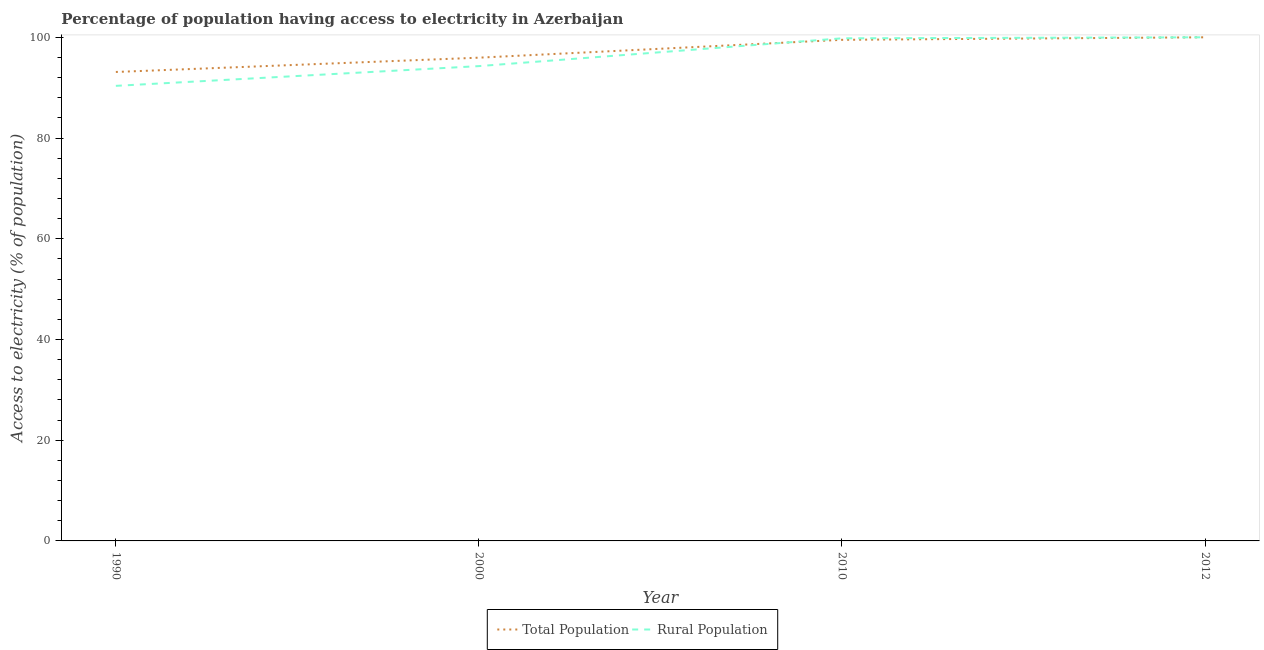How many different coloured lines are there?
Your answer should be compact. 2. What is the percentage of population having access to electricity in 2000?
Offer a terse response. 95.96. Across all years, what is the minimum percentage of population having access to electricity?
Your answer should be compact. 93.12. What is the total percentage of population having access to electricity in the graph?
Keep it short and to the point. 388.57. What is the difference between the percentage of population having access to electricity in 1990 and that in 2010?
Give a very brief answer. -6.38. What is the difference between the percentage of population having access to electricity in 1990 and the percentage of rural population having access to electricity in 2012?
Provide a succinct answer. -6.88. What is the average percentage of rural population having access to electricity per year?
Offer a very short reply. 96.11. What is the ratio of the percentage of population having access to electricity in 2000 to that in 2010?
Provide a succinct answer. 0.96. Is the percentage of population having access to electricity in 1990 less than that in 2000?
Your answer should be compact. Yes. What is the difference between the highest and the second highest percentage of rural population having access to electricity?
Offer a very short reply. 0.2. What is the difference between the highest and the lowest percentage of rural population having access to electricity?
Your answer should be compact. 9.64. In how many years, is the percentage of rural population having access to electricity greater than the average percentage of rural population having access to electricity taken over all years?
Keep it short and to the point. 2. Does the percentage of population having access to electricity monotonically increase over the years?
Provide a succinct answer. Yes. Is the percentage of rural population having access to electricity strictly less than the percentage of population having access to electricity over the years?
Your response must be concise. No. How many years are there in the graph?
Your response must be concise. 4. Are the values on the major ticks of Y-axis written in scientific E-notation?
Your response must be concise. No. Does the graph contain any zero values?
Your answer should be compact. No. How are the legend labels stacked?
Give a very brief answer. Horizontal. What is the title of the graph?
Give a very brief answer. Percentage of population having access to electricity in Azerbaijan. Does "Investments" appear as one of the legend labels in the graph?
Give a very brief answer. No. What is the label or title of the Y-axis?
Your answer should be very brief. Access to electricity (% of population). What is the Access to electricity (% of population) in Total Population in 1990?
Keep it short and to the point. 93.12. What is the Access to electricity (% of population) in Rural Population in 1990?
Provide a short and direct response. 90.36. What is the Access to electricity (% of population) in Total Population in 2000?
Ensure brevity in your answer.  95.96. What is the Access to electricity (% of population) in Rural Population in 2000?
Provide a short and direct response. 94.28. What is the Access to electricity (% of population) of Total Population in 2010?
Your response must be concise. 99.5. What is the Access to electricity (% of population) in Rural Population in 2010?
Your answer should be compact. 99.8. What is the Access to electricity (% of population) of Rural Population in 2012?
Offer a very short reply. 100. Across all years, what is the minimum Access to electricity (% of population) of Total Population?
Your answer should be very brief. 93.12. Across all years, what is the minimum Access to electricity (% of population) in Rural Population?
Make the answer very short. 90.36. What is the total Access to electricity (% of population) of Total Population in the graph?
Provide a succinct answer. 388.57. What is the total Access to electricity (% of population) of Rural Population in the graph?
Offer a terse response. 384.44. What is the difference between the Access to electricity (% of population) of Total Population in 1990 and that in 2000?
Keep it short and to the point. -2.84. What is the difference between the Access to electricity (% of population) in Rural Population in 1990 and that in 2000?
Provide a succinct answer. -3.92. What is the difference between the Access to electricity (% of population) in Total Population in 1990 and that in 2010?
Give a very brief answer. -6.38. What is the difference between the Access to electricity (% of population) in Rural Population in 1990 and that in 2010?
Keep it short and to the point. -9.44. What is the difference between the Access to electricity (% of population) of Total Population in 1990 and that in 2012?
Offer a terse response. -6.88. What is the difference between the Access to electricity (% of population) of Rural Population in 1990 and that in 2012?
Make the answer very short. -9.64. What is the difference between the Access to electricity (% of population) in Total Population in 2000 and that in 2010?
Provide a short and direct response. -3.54. What is the difference between the Access to electricity (% of population) of Rural Population in 2000 and that in 2010?
Give a very brief answer. -5.52. What is the difference between the Access to electricity (% of population) of Total Population in 2000 and that in 2012?
Your answer should be compact. -4.04. What is the difference between the Access to electricity (% of population) in Rural Population in 2000 and that in 2012?
Your answer should be very brief. -5.72. What is the difference between the Access to electricity (% of population) of Total Population in 1990 and the Access to electricity (% of population) of Rural Population in 2000?
Your response must be concise. -1.17. What is the difference between the Access to electricity (% of population) of Total Population in 1990 and the Access to electricity (% of population) of Rural Population in 2010?
Provide a short and direct response. -6.68. What is the difference between the Access to electricity (% of population) of Total Population in 1990 and the Access to electricity (% of population) of Rural Population in 2012?
Your response must be concise. -6.88. What is the difference between the Access to electricity (% of population) of Total Population in 2000 and the Access to electricity (% of population) of Rural Population in 2010?
Keep it short and to the point. -3.84. What is the difference between the Access to electricity (% of population) of Total Population in 2000 and the Access to electricity (% of population) of Rural Population in 2012?
Your response must be concise. -4.04. What is the difference between the Access to electricity (% of population) of Total Population in 2010 and the Access to electricity (% of population) of Rural Population in 2012?
Your answer should be very brief. -0.5. What is the average Access to electricity (% of population) of Total Population per year?
Offer a terse response. 97.14. What is the average Access to electricity (% of population) in Rural Population per year?
Your response must be concise. 96.11. In the year 1990, what is the difference between the Access to electricity (% of population) in Total Population and Access to electricity (% of population) in Rural Population?
Offer a terse response. 2.76. In the year 2000, what is the difference between the Access to electricity (% of population) in Total Population and Access to electricity (% of population) in Rural Population?
Offer a terse response. 1.68. In the year 2010, what is the difference between the Access to electricity (% of population) of Total Population and Access to electricity (% of population) of Rural Population?
Keep it short and to the point. -0.3. What is the ratio of the Access to electricity (% of population) in Total Population in 1990 to that in 2000?
Provide a short and direct response. 0.97. What is the ratio of the Access to electricity (% of population) in Rural Population in 1990 to that in 2000?
Offer a very short reply. 0.96. What is the ratio of the Access to electricity (% of population) of Total Population in 1990 to that in 2010?
Make the answer very short. 0.94. What is the ratio of the Access to electricity (% of population) in Rural Population in 1990 to that in 2010?
Provide a short and direct response. 0.91. What is the ratio of the Access to electricity (% of population) in Total Population in 1990 to that in 2012?
Offer a very short reply. 0.93. What is the ratio of the Access to electricity (% of population) of Rural Population in 1990 to that in 2012?
Give a very brief answer. 0.9. What is the ratio of the Access to electricity (% of population) in Total Population in 2000 to that in 2010?
Make the answer very short. 0.96. What is the ratio of the Access to electricity (% of population) in Rural Population in 2000 to that in 2010?
Your answer should be very brief. 0.94. What is the ratio of the Access to electricity (% of population) in Total Population in 2000 to that in 2012?
Offer a terse response. 0.96. What is the ratio of the Access to electricity (% of population) in Rural Population in 2000 to that in 2012?
Your response must be concise. 0.94. What is the difference between the highest and the lowest Access to electricity (% of population) in Total Population?
Your answer should be compact. 6.88. What is the difference between the highest and the lowest Access to electricity (% of population) of Rural Population?
Your answer should be compact. 9.64. 